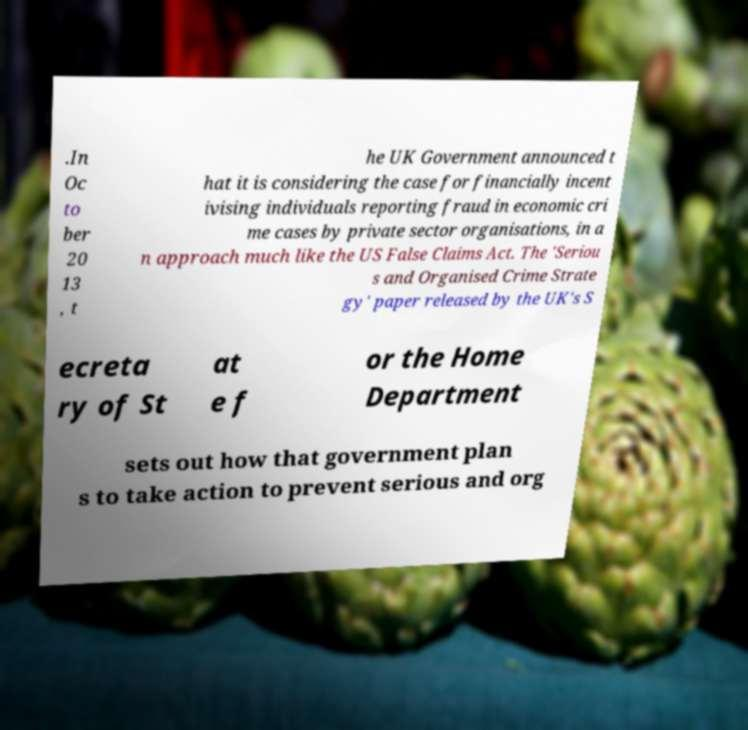I need the written content from this picture converted into text. Can you do that? .In Oc to ber 20 13 , t he UK Government announced t hat it is considering the case for financially incent ivising individuals reporting fraud in economic cri me cases by private sector organisations, in a n approach much like the US False Claims Act. The 'Seriou s and Organised Crime Strate gy' paper released by the UK's S ecreta ry of St at e f or the Home Department sets out how that government plan s to take action to prevent serious and org 